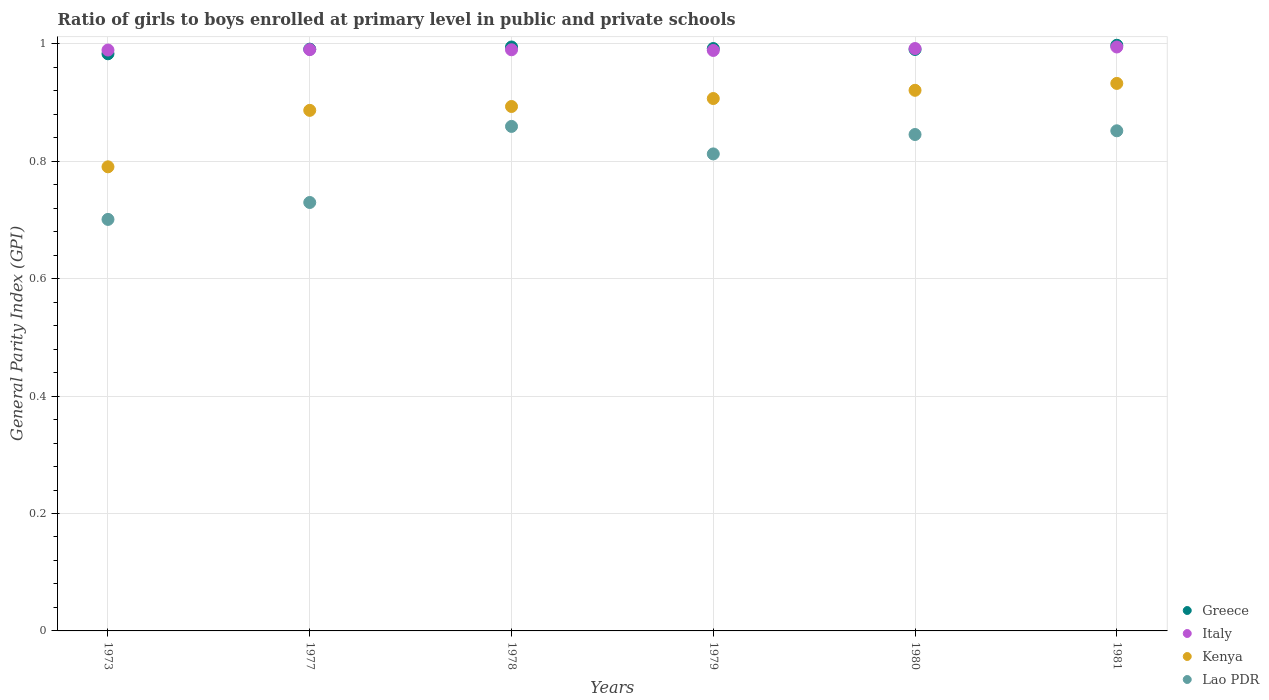Is the number of dotlines equal to the number of legend labels?
Keep it short and to the point. Yes. What is the general parity index in Italy in 1980?
Keep it short and to the point. 0.99. Across all years, what is the maximum general parity index in Italy?
Offer a terse response. 0.99. Across all years, what is the minimum general parity index in Kenya?
Make the answer very short. 0.79. In which year was the general parity index in Italy maximum?
Offer a terse response. 1981. What is the total general parity index in Lao PDR in the graph?
Ensure brevity in your answer.  4.8. What is the difference between the general parity index in Lao PDR in 1978 and that in 1980?
Offer a very short reply. 0.01. What is the difference between the general parity index in Lao PDR in 1973 and the general parity index in Italy in 1977?
Provide a short and direct response. -0.29. What is the average general parity index in Italy per year?
Provide a succinct answer. 0.99. In the year 1978, what is the difference between the general parity index in Italy and general parity index in Greece?
Offer a very short reply. -0. What is the ratio of the general parity index in Kenya in 1978 to that in 1980?
Give a very brief answer. 0.97. Is the general parity index in Kenya in 1973 less than that in 1978?
Your answer should be very brief. Yes. What is the difference between the highest and the second highest general parity index in Greece?
Provide a short and direct response. 0. What is the difference between the highest and the lowest general parity index in Kenya?
Make the answer very short. 0.14. In how many years, is the general parity index in Greece greater than the average general parity index in Greece taken over all years?
Ensure brevity in your answer.  3. Does the general parity index in Lao PDR monotonically increase over the years?
Give a very brief answer. No. Is the general parity index in Kenya strictly greater than the general parity index in Lao PDR over the years?
Give a very brief answer. Yes. How many dotlines are there?
Make the answer very short. 4. What is the difference between two consecutive major ticks on the Y-axis?
Your answer should be very brief. 0.2. Does the graph contain grids?
Give a very brief answer. Yes. How are the legend labels stacked?
Ensure brevity in your answer.  Vertical. What is the title of the graph?
Give a very brief answer. Ratio of girls to boys enrolled at primary level in public and private schools. What is the label or title of the X-axis?
Ensure brevity in your answer.  Years. What is the label or title of the Y-axis?
Your answer should be compact. General Parity Index (GPI). What is the General Parity Index (GPI) in Greece in 1973?
Your answer should be very brief. 0.98. What is the General Parity Index (GPI) of Italy in 1973?
Provide a succinct answer. 0.99. What is the General Parity Index (GPI) in Kenya in 1973?
Your answer should be compact. 0.79. What is the General Parity Index (GPI) in Lao PDR in 1973?
Keep it short and to the point. 0.7. What is the General Parity Index (GPI) of Greece in 1977?
Your answer should be compact. 0.99. What is the General Parity Index (GPI) in Italy in 1977?
Give a very brief answer. 0.99. What is the General Parity Index (GPI) in Kenya in 1977?
Offer a very short reply. 0.89. What is the General Parity Index (GPI) of Lao PDR in 1977?
Provide a short and direct response. 0.73. What is the General Parity Index (GPI) in Greece in 1978?
Offer a very short reply. 0.99. What is the General Parity Index (GPI) in Italy in 1978?
Your response must be concise. 0.99. What is the General Parity Index (GPI) in Kenya in 1978?
Ensure brevity in your answer.  0.89. What is the General Parity Index (GPI) in Lao PDR in 1978?
Keep it short and to the point. 0.86. What is the General Parity Index (GPI) in Greece in 1979?
Give a very brief answer. 0.99. What is the General Parity Index (GPI) in Italy in 1979?
Keep it short and to the point. 0.99. What is the General Parity Index (GPI) in Kenya in 1979?
Make the answer very short. 0.91. What is the General Parity Index (GPI) of Lao PDR in 1979?
Your answer should be very brief. 0.81. What is the General Parity Index (GPI) of Greece in 1980?
Give a very brief answer. 0.99. What is the General Parity Index (GPI) of Italy in 1980?
Offer a very short reply. 0.99. What is the General Parity Index (GPI) in Kenya in 1980?
Offer a terse response. 0.92. What is the General Parity Index (GPI) in Lao PDR in 1980?
Provide a short and direct response. 0.85. What is the General Parity Index (GPI) of Greece in 1981?
Your response must be concise. 1. What is the General Parity Index (GPI) in Italy in 1981?
Ensure brevity in your answer.  0.99. What is the General Parity Index (GPI) of Kenya in 1981?
Provide a succinct answer. 0.93. What is the General Parity Index (GPI) in Lao PDR in 1981?
Your answer should be very brief. 0.85. Across all years, what is the maximum General Parity Index (GPI) of Greece?
Offer a very short reply. 1. Across all years, what is the maximum General Parity Index (GPI) of Italy?
Ensure brevity in your answer.  0.99. Across all years, what is the maximum General Parity Index (GPI) in Kenya?
Ensure brevity in your answer.  0.93. Across all years, what is the maximum General Parity Index (GPI) in Lao PDR?
Your answer should be compact. 0.86. Across all years, what is the minimum General Parity Index (GPI) in Greece?
Your answer should be compact. 0.98. Across all years, what is the minimum General Parity Index (GPI) in Italy?
Give a very brief answer. 0.99. Across all years, what is the minimum General Parity Index (GPI) of Kenya?
Your answer should be very brief. 0.79. Across all years, what is the minimum General Parity Index (GPI) of Lao PDR?
Provide a succinct answer. 0.7. What is the total General Parity Index (GPI) of Greece in the graph?
Your response must be concise. 5.95. What is the total General Parity Index (GPI) of Italy in the graph?
Offer a terse response. 5.95. What is the total General Parity Index (GPI) in Kenya in the graph?
Provide a short and direct response. 5.33. What is the total General Parity Index (GPI) of Lao PDR in the graph?
Provide a short and direct response. 4.8. What is the difference between the General Parity Index (GPI) of Greece in 1973 and that in 1977?
Your response must be concise. -0.01. What is the difference between the General Parity Index (GPI) in Italy in 1973 and that in 1977?
Give a very brief answer. -0. What is the difference between the General Parity Index (GPI) of Kenya in 1973 and that in 1977?
Your answer should be compact. -0.1. What is the difference between the General Parity Index (GPI) in Lao PDR in 1973 and that in 1977?
Offer a very short reply. -0.03. What is the difference between the General Parity Index (GPI) of Greece in 1973 and that in 1978?
Give a very brief answer. -0.01. What is the difference between the General Parity Index (GPI) of Italy in 1973 and that in 1978?
Provide a short and direct response. -0. What is the difference between the General Parity Index (GPI) of Kenya in 1973 and that in 1978?
Make the answer very short. -0.1. What is the difference between the General Parity Index (GPI) in Lao PDR in 1973 and that in 1978?
Your answer should be compact. -0.16. What is the difference between the General Parity Index (GPI) of Greece in 1973 and that in 1979?
Keep it short and to the point. -0.01. What is the difference between the General Parity Index (GPI) of Italy in 1973 and that in 1979?
Provide a short and direct response. 0. What is the difference between the General Parity Index (GPI) of Kenya in 1973 and that in 1979?
Your response must be concise. -0.12. What is the difference between the General Parity Index (GPI) of Lao PDR in 1973 and that in 1979?
Your answer should be very brief. -0.11. What is the difference between the General Parity Index (GPI) in Greece in 1973 and that in 1980?
Keep it short and to the point. -0.01. What is the difference between the General Parity Index (GPI) in Italy in 1973 and that in 1980?
Make the answer very short. -0. What is the difference between the General Parity Index (GPI) of Kenya in 1973 and that in 1980?
Provide a succinct answer. -0.13. What is the difference between the General Parity Index (GPI) of Lao PDR in 1973 and that in 1980?
Give a very brief answer. -0.14. What is the difference between the General Parity Index (GPI) of Greece in 1973 and that in 1981?
Make the answer very short. -0.01. What is the difference between the General Parity Index (GPI) in Italy in 1973 and that in 1981?
Offer a very short reply. -0.01. What is the difference between the General Parity Index (GPI) in Kenya in 1973 and that in 1981?
Provide a succinct answer. -0.14. What is the difference between the General Parity Index (GPI) of Lao PDR in 1973 and that in 1981?
Ensure brevity in your answer.  -0.15. What is the difference between the General Parity Index (GPI) of Greece in 1977 and that in 1978?
Provide a succinct answer. -0. What is the difference between the General Parity Index (GPI) in Kenya in 1977 and that in 1978?
Keep it short and to the point. -0.01. What is the difference between the General Parity Index (GPI) of Lao PDR in 1977 and that in 1978?
Offer a very short reply. -0.13. What is the difference between the General Parity Index (GPI) in Greece in 1977 and that in 1979?
Provide a short and direct response. -0. What is the difference between the General Parity Index (GPI) of Italy in 1977 and that in 1979?
Provide a succinct answer. 0. What is the difference between the General Parity Index (GPI) in Kenya in 1977 and that in 1979?
Your answer should be compact. -0.02. What is the difference between the General Parity Index (GPI) of Lao PDR in 1977 and that in 1979?
Keep it short and to the point. -0.08. What is the difference between the General Parity Index (GPI) in Greece in 1977 and that in 1980?
Provide a succinct answer. 0. What is the difference between the General Parity Index (GPI) of Italy in 1977 and that in 1980?
Give a very brief answer. -0. What is the difference between the General Parity Index (GPI) in Kenya in 1977 and that in 1980?
Keep it short and to the point. -0.03. What is the difference between the General Parity Index (GPI) in Lao PDR in 1977 and that in 1980?
Provide a short and direct response. -0.12. What is the difference between the General Parity Index (GPI) of Greece in 1977 and that in 1981?
Provide a succinct answer. -0.01. What is the difference between the General Parity Index (GPI) of Italy in 1977 and that in 1981?
Provide a short and direct response. -0. What is the difference between the General Parity Index (GPI) of Kenya in 1977 and that in 1981?
Offer a very short reply. -0.05. What is the difference between the General Parity Index (GPI) in Lao PDR in 1977 and that in 1981?
Provide a short and direct response. -0.12. What is the difference between the General Parity Index (GPI) in Greece in 1978 and that in 1979?
Keep it short and to the point. 0. What is the difference between the General Parity Index (GPI) of Italy in 1978 and that in 1979?
Keep it short and to the point. 0. What is the difference between the General Parity Index (GPI) in Kenya in 1978 and that in 1979?
Your answer should be very brief. -0.01. What is the difference between the General Parity Index (GPI) in Lao PDR in 1978 and that in 1979?
Make the answer very short. 0.05. What is the difference between the General Parity Index (GPI) in Greece in 1978 and that in 1980?
Keep it short and to the point. 0. What is the difference between the General Parity Index (GPI) in Italy in 1978 and that in 1980?
Provide a short and direct response. -0. What is the difference between the General Parity Index (GPI) in Kenya in 1978 and that in 1980?
Your answer should be compact. -0.03. What is the difference between the General Parity Index (GPI) of Lao PDR in 1978 and that in 1980?
Ensure brevity in your answer.  0.01. What is the difference between the General Parity Index (GPI) in Greece in 1978 and that in 1981?
Ensure brevity in your answer.  -0. What is the difference between the General Parity Index (GPI) of Italy in 1978 and that in 1981?
Your answer should be compact. -0. What is the difference between the General Parity Index (GPI) of Kenya in 1978 and that in 1981?
Your answer should be compact. -0.04. What is the difference between the General Parity Index (GPI) in Lao PDR in 1978 and that in 1981?
Ensure brevity in your answer.  0.01. What is the difference between the General Parity Index (GPI) in Greece in 1979 and that in 1980?
Offer a terse response. 0. What is the difference between the General Parity Index (GPI) of Italy in 1979 and that in 1980?
Offer a very short reply. -0. What is the difference between the General Parity Index (GPI) of Kenya in 1979 and that in 1980?
Your response must be concise. -0.01. What is the difference between the General Parity Index (GPI) of Lao PDR in 1979 and that in 1980?
Provide a succinct answer. -0.03. What is the difference between the General Parity Index (GPI) in Greece in 1979 and that in 1981?
Your answer should be very brief. -0.01. What is the difference between the General Parity Index (GPI) of Italy in 1979 and that in 1981?
Ensure brevity in your answer.  -0.01. What is the difference between the General Parity Index (GPI) of Kenya in 1979 and that in 1981?
Ensure brevity in your answer.  -0.03. What is the difference between the General Parity Index (GPI) of Lao PDR in 1979 and that in 1981?
Keep it short and to the point. -0.04. What is the difference between the General Parity Index (GPI) in Greece in 1980 and that in 1981?
Give a very brief answer. -0.01. What is the difference between the General Parity Index (GPI) in Italy in 1980 and that in 1981?
Provide a short and direct response. -0. What is the difference between the General Parity Index (GPI) of Kenya in 1980 and that in 1981?
Keep it short and to the point. -0.01. What is the difference between the General Parity Index (GPI) of Lao PDR in 1980 and that in 1981?
Offer a very short reply. -0.01. What is the difference between the General Parity Index (GPI) in Greece in 1973 and the General Parity Index (GPI) in Italy in 1977?
Provide a succinct answer. -0.01. What is the difference between the General Parity Index (GPI) in Greece in 1973 and the General Parity Index (GPI) in Kenya in 1977?
Ensure brevity in your answer.  0.1. What is the difference between the General Parity Index (GPI) of Greece in 1973 and the General Parity Index (GPI) of Lao PDR in 1977?
Ensure brevity in your answer.  0.25. What is the difference between the General Parity Index (GPI) of Italy in 1973 and the General Parity Index (GPI) of Kenya in 1977?
Make the answer very short. 0.1. What is the difference between the General Parity Index (GPI) in Italy in 1973 and the General Parity Index (GPI) in Lao PDR in 1977?
Your response must be concise. 0.26. What is the difference between the General Parity Index (GPI) of Kenya in 1973 and the General Parity Index (GPI) of Lao PDR in 1977?
Your response must be concise. 0.06. What is the difference between the General Parity Index (GPI) of Greece in 1973 and the General Parity Index (GPI) of Italy in 1978?
Ensure brevity in your answer.  -0.01. What is the difference between the General Parity Index (GPI) of Greece in 1973 and the General Parity Index (GPI) of Kenya in 1978?
Ensure brevity in your answer.  0.09. What is the difference between the General Parity Index (GPI) in Greece in 1973 and the General Parity Index (GPI) in Lao PDR in 1978?
Ensure brevity in your answer.  0.12. What is the difference between the General Parity Index (GPI) of Italy in 1973 and the General Parity Index (GPI) of Kenya in 1978?
Offer a very short reply. 0.1. What is the difference between the General Parity Index (GPI) in Italy in 1973 and the General Parity Index (GPI) in Lao PDR in 1978?
Your answer should be very brief. 0.13. What is the difference between the General Parity Index (GPI) of Kenya in 1973 and the General Parity Index (GPI) of Lao PDR in 1978?
Your response must be concise. -0.07. What is the difference between the General Parity Index (GPI) in Greece in 1973 and the General Parity Index (GPI) in Italy in 1979?
Your answer should be compact. -0.01. What is the difference between the General Parity Index (GPI) of Greece in 1973 and the General Parity Index (GPI) of Kenya in 1979?
Provide a short and direct response. 0.08. What is the difference between the General Parity Index (GPI) of Greece in 1973 and the General Parity Index (GPI) of Lao PDR in 1979?
Offer a very short reply. 0.17. What is the difference between the General Parity Index (GPI) of Italy in 1973 and the General Parity Index (GPI) of Kenya in 1979?
Provide a succinct answer. 0.08. What is the difference between the General Parity Index (GPI) in Italy in 1973 and the General Parity Index (GPI) in Lao PDR in 1979?
Keep it short and to the point. 0.18. What is the difference between the General Parity Index (GPI) of Kenya in 1973 and the General Parity Index (GPI) of Lao PDR in 1979?
Keep it short and to the point. -0.02. What is the difference between the General Parity Index (GPI) in Greece in 1973 and the General Parity Index (GPI) in Italy in 1980?
Provide a succinct answer. -0.01. What is the difference between the General Parity Index (GPI) in Greece in 1973 and the General Parity Index (GPI) in Kenya in 1980?
Provide a succinct answer. 0.06. What is the difference between the General Parity Index (GPI) in Greece in 1973 and the General Parity Index (GPI) in Lao PDR in 1980?
Your response must be concise. 0.14. What is the difference between the General Parity Index (GPI) in Italy in 1973 and the General Parity Index (GPI) in Kenya in 1980?
Make the answer very short. 0.07. What is the difference between the General Parity Index (GPI) in Italy in 1973 and the General Parity Index (GPI) in Lao PDR in 1980?
Keep it short and to the point. 0.14. What is the difference between the General Parity Index (GPI) in Kenya in 1973 and the General Parity Index (GPI) in Lao PDR in 1980?
Give a very brief answer. -0.06. What is the difference between the General Parity Index (GPI) of Greece in 1973 and the General Parity Index (GPI) of Italy in 1981?
Offer a very short reply. -0.01. What is the difference between the General Parity Index (GPI) in Greece in 1973 and the General Parity Index (GPI) in Kenya in 1981?
Your answer should be compact. 0.05. What is the difference between the General Parity Index (GPI) of Greece in 1973 and the General Parity Index (GPI) of Lao PDR in 1981?
Keep it short and to the point. 0.13. What is the difference between the General Parity Index (GPI) of Italy in 1973 and the General Parity Index (GPI) of Kenya in 1981?
Provide a short and direct response. 0.06. What is the difference between the General Parity Index (GPI) of Italy in 1973 and the General Parity Index (GPI) of Lao PDR in 1981?
Ensure brevity in your answer.  0.14. What is the difference between the General Parity Index (GPI) of Kenya in 1973 and the General Parity Index (GPI) of Lao PDR in 1981?
Offer a very short reply. -0.06. What is the difference between the General Parity Index (GPI) in Greece in 1977 and the General Parity Index (GPI) in Italy in 1978?
Keep it short and to the point. 0. What is the difference between the General Parity Index (GPI) of Greece in 1977 and the General Parity Index (GPI) of Kenya in 1978?
Keep it short and to the point. 0.1. What is the difference between the General Parity Index (GPI) in Greece in 1977 and the General Parity Index (GPI) in Lao PDR in 1978?
Provide a short and direct response. 0.13. What is the difference between the General Parity Index (GPI) in Italy in 1977 and the General Parity Index (GPI) in Kenya in 1978?
Keep it short and to the point. 0.1. What is the difference between the General Parity Index (GPI) of Italy in 1977 and the General Parity Index (GPI) of Lao PDR in 1978?
Give a very brief answer. 0.13. What is the difference between the General Parity Index (GPI) of Kenya in 1977 and the General Parity Index (GPI) of Lao PDR in 1978?
Make the answer very short. 0.03. What is the difference between the General Parity Index (GPI) in Greece in 1977 and the General Parity Index (GPI) in Italy in 1979?
Provide a short and direct response. 0. What is the difference between the General Parity Index (GPI) of Greece in 1977 and the General Parity Index (GPI) of Kenya in 1979?
Your response must be concise. 0.08. What is the difference between the General Parity Index (GPI) in Greece in 1977 and the General Parity Index (GPI) in Lao PDR in 1979?
Provide a short and direct response. 0.18. What is the difference between the General Parity Index (GPI) in Italy in 1977 and the General Parity Index (GPI) in Kenya in 1979?
Offer a very short reply. 0.08. What is the difference between the General Parity Index (GPI) in Italy in 1977 and the General Parity Index (GPI) in Lao PDR in 1979?
Offer a terse response. 0.18. What is the difference between the General Parity Index (GPI) of Kenya in 1977 and the General Parity Index (GPI) of Lao PDR in 1979?
Provide a short and direct response. 0.07. What is the difference between the General Parity Index (GPI) in Greece in 1977 and the General Parity Index (GPI) in Italy in 1980?
Keep it short and to the point. -0. What is the difference between the General Parity Index (GPI) in Greece in 1977 and the General Parity Index (GPI) in Kenya in 1980?
Provide a short and direct response. 0.07. What is the difference between the General Parity Index (GPI) of Greece in 1977 and the General Parity Index (GPI) of Lao PDR in 1980?
Your response must be concise. 0.15. What is the difference between the General Parity Index (GPI) of Italy in 1977 and the General Parity Index (GPI) of Kenya in 1980?
Give a very brief answer. 0.07. What is the difference between the General Parity Index (GPI) in Italy in 1977 and the General Parity Index (GPI) in Lao PDR in 1980?
Keep it short and to the point. 0.14. What is the difference between the General Parity Index (GPI) of Kenya in 1977 and the General Parity Index (GPI) of Lao PDR in 1980?
Offer a terse response. 0.04. What is the difference between the General Parity Index (GPI) in Greece in 1977 and the General Parity Index (GPI) in Italy in 1981?
Give a very brief answer. -0. What is the difference between the General Parity Index (GPI) in Greece in 1977 and the General Parity Index (GPI) in Kenya in 1981?
Provide a short and direct response. 0.06. What is the difference between the General Parity Index (GPI) in Greece in 1977 and the General Parity Index (GPI) in Lao PDR in 1981?
Offer a very short reply. 0.14. What is the difference between the General Parity Index (GPI) in Italy in 1977 and the General Parity Index (GPI) in Kenya in 1981?
Make the answer very short. 0.06. What is the difference between the General Parity Index (GPI) of Italy in 1977 and the General Parity Index (GPI) of Lao PDR in 1981?
Offer a terse response. 0.14. What is the difference between the General Parity Index (GPI) in Kenya in 1977 and the General Parity Index (GPI) in Lao PDR in 1981?
Make the answer very short. 0.03. What is the difference between the General Parity Index (GPI) in Greece in 1978 and the General Parity Index (GPI) in Italy in 1979?
Make the answer very short. 0.01. What is the difference between the General Parity Index (GPI) in Greece in 1978 and the General Parity Index (GPI) in Kenya in 1979?
Your response must be concise. 0.09. What is the difference between the General Parity Index (GPI) in Greece in 1978 and the General Parity Index (GPI) in Lao PDR in 1979?
Ensure brevity in your answer.  0.18. What is the difference between the General Parity Index (GPI) of Italy in 1978 and the General Parity Index (GPI) of Kenya in 1979?
Your answer should be very brief. 0.08. What is the difference between the General Parity Index (GPI) of Italy in 1978 and the General Parity Index (GPI) of Lao PDR in 1979?
Your answer should be compact. 0.18. What is the difference between the General Parity Index (GPI) in Kenya in 1978 and the General Parity Index (GPI) in Lao PDR in 1979?
Your answer should be compact. 0.08. What is the difference between the General Parity Index (GPI) of Greece in 1978 and the General Parity Index (GPI) of Italy in 1980?
Ensure brevity in your answer.  0. What is the difference between the General Parity Index (GPI) of Greece in 1978 and the General Parity Index (GPI) of Kenya in 1980?
Ensure brevity in your answer.  0.07. What is the difference between the General Parity Index (GPI) in Greece in 1978 and the General Parity Index (GPI) in Lao PDR in 1980?
Keep it short and to the point. 0.15. What is the difference between the General Parity Index (GPI) of Italy in 1978 and the General Parity Index (GPI) of Kenya in 1980?
Provide a succinct answer. 0.07. What is the difference between the General Parity Index (GPI) of Italy in 1978 and the General Parity Index (GPI) of Lao PDR in 1980?
Provide a succinct answer. 0.14. What is the difference between the General Parity Index (GPI) of Kenya in 1978 and the General Parity Index (GPI) of Lao PDR in 1980?
Offer a very short reply. 0.05. What is the difference between the General Parity Index (GPI) of Greece in 1978 and the General Parity Index (GPI) of Kenya in 1981?
Make the answer very short. 0.06. What is the difference between the General Parity Index (GPI) in Greece in 1978 and the General Parity Index (GPI) in Lao PDR in 1981?
Your answer should be compact. 0.14. What is the difference between the General Parity Index (GPI) in Italy in 1978 and the General Parity Index (GPI) in Kenya in 1981?
Offer a very short reply. 0.06. What is the difference between the General Parity Index (GPI) in Italy in 1978 and the General Parity Index (GPI) in Lao PDR in 1981?
Your answer should be very brief. 0.14. What is the difference between the General Parity Index (GPI) of Kenya in 1978 and the General Parity Index (GPI) of Lao PDR in 1981?
Your response must be concise. 0.04. What is the difference between the General Parity Index (GPI) of Greece in 1979 and the General Parity Index (GPI) of Italy in 1980?
Offer a very short reply. 0. What is the difference between the General Parity Index (GPI) in Greece in 1979 and the General Parity Index (GPI) in Kenya in 1980?
Provide a succinct answer. 0.07. What is the difference between the General Parity Index (GPI) in Greece in 1979 and the General Parity Index (GPI) in Lao PDR in 1980?
Ensure brevity in your answer.  0.15. What is the difference between the General Parity Index (GPI) of Italy in 1979 and the General Parity Index (GPI) of Kenya in 1980?
Offer a very short reply. 0.07. What is the difference between the General Parity Index (GPI) in Italy in 1979 and the General Parity Index (GPI) in Lao PDR in 1980?
Keep it short and to the point. 0.14. What is the difference between the General Parity Index (GPI) in Kenya in 1979 and the General Parity Index (GPI) in Lao PDR in 1980?
Keep it short and to the point. 0.06. What is the difference between the General Parity Index (GPI) of Greece in 1979 and the General Parity Index (GPI) of Italy in 1981?
Make the answer very short. -0. What is the difference between the General Parity Index (GPI) in Greece in 1979 and the General Parity Index (GPI) in Kenya in 1981?
Give a very brief answer. 0.06. What is the difference between the General Parity Index (GPI) of Greece in 1979 and the General Parity Index (GPI) of Lao PDR in 1981?
Your response must be concise. 0.14. What is the difference between the General Parity Index (GPI) in Italy in 1979 and the General Parity Index (GPI) in Kenya in 1981?
Your answer should be compact. 0.06. What is the difference between the General Parity Index (GPI) in Italy in 1979 and the General Parity Index (GPI) in Lao PDR in 1981?
Give a very brief answer. 0.14. What is the difference between the General Parity Index (GPI) in Kenya in 1979 and the General Parity Index (GPI) in Lao PDR in 1981?
Your response must be concise. 0.06. What is the difference between the General Parity Index (GPI) of Greece in 1980 and the General Parity Index (GPI) of Italy in 1981?
Ensure brevity in your answer.  -0. What is the difference between the General Parity Index (GPI) in Greece in 1980 and the General Parity Index (GPI) in Kenya in 1981?
Keep it short and to the point. 0.06. What is the difference between the General Parity Index (GPI) of Greece in 1980 and the General Parity Index (GPI) of Lao PDR in 1981?
Your response must be concise. 0.14. What is the difference between the General Parity Index (GPI) of Italy in 1980 and the General Parity Index (GPI) of Kenya in 1981?
Make the answer very short. 0.06. What is the difference between the General Parity Index (GPI) of Italy in 1980 and the General Parity Index (GPI) of Lao PDR in 1981?
Offer a terse response. 0.14. What is the difference between the General Parity Index (GPI) in Kenya in 1980 and the General Parity Index (GPI) in Lao PDR in 1981?
Offer a very short reply. 0.07. What is the average General Parity Index (GPI) in Italy per year?
Offer a very short reply. 0.99. What is the average General Parity Index (GPI) of Kenya per year?
Offer a terse response. 0.89. What is the average General Parity Index (GPI) in Lao PDR per year?
Make the answer very short. 0.8. In the year 1973, what is the difference between the General Parity Index (GPI) of Greece and General Parity Index (GPI) of Italy?
Ensure brevity in your answer.  -0.01. In the year 1973, what is the difference between the General Parity Index (GPI) in Greece and General Parity Index (GPI) in Kenya?
Your answer should be very brief. 0.19. In the year 1973, what is the difference between the General Parity Index (GPI) in Greece and General Parity Index (GPI) in Lao PDR?
Offer a very short reply. 0.28. In the year 1973, what is the difference between the General Parity Index (GPI) of Italy and General Parity Index (GPI) of Kenya?
Ensure brevity in your answer.  0.2. In the year 1973, what is the difference between the General Parity Index (GPI) of Italy and General Parity Index (GPI) of Lao PDR?
Provide a short and direct response. 0.29. In the year 1973, what is the difference between the General Parity Index (GPI) in Kenya and General Parity Index (GPI) in Lao PDR?
Make the answer very short. 0.09. In the year 1977, what is the difference between the General Parity Index (GPI) in Greece and General Parity Index (GPI) in Italy?
Give a very brief answer. 0. In the year 1977, what is the difference between the General Parity Index (GPI) in Greece and General Parity Index (GPI) in Kenya?
Provide a short and direct response. 0.1. In the year 1977, what is the difference between the General Parity Index (GPI) of Greece and General Parity Index (GPI) of Lao PDR?
Offer a very short reply. 0.26. In the year 1977, what is the difference between the General Parity Index (GPI) in Italy and General Parity Index (GPI) in Kenya?
Your answer should be compact. 0.1. In the year 1977, what is the difference between the General Parity Index (GPI) in Italy and General Parity Index (GPI) in Lao PDR?
Keep it short and to the point. 0.26. In the year 1977, what is the difference between the General Parity Index (GPI) in Kenya and General Parity Index (GPI) in Lao PDR?
Provide a succinct answer. 0.16. In the year 1978, what is the difference between the General Parity Index (GPI) in Greece and General Parity Index (GPI) in Italy?
Provide a succinct answer. 0. In the year 1978, what is the difference between the General Parity Index (GPI) in Greece and General Parity Index (GPI) in Kenya?
Offer a terse response. 0.1. In the year 1978, what is the difference between the General Parity Index (GPI) of Greece and General Parity Index (GPI) of Lao PDR?
Keep it short and to the point. 0.14. In the year 1978, what is the difference between the General Parity Index (GPI) of Italy and General Parity Index (GPI) of Kenya?
Provide a short and direct response. 0.1. In the year 1978, what is the difference between the General Parity Index (GPI) of Italy and General Parity Index (GPI) of Lao PDR?
Your response must be concise. 0.13. In the year 1978, what is the difference between the General Parity Index (GPI) of Kenya and General Parity Index (GPI) of Lao PDR?
Make the answer very short. 0.03. In the year 1979, what is the difference between the General Parity Index (GPI) of Greece and General Parity Index (GPI) of Italy?
Make the answer very short. 0. In the year 1979, what is the difference between the General Parity Index (GPI) in Greece and General Parity Index (GPI) in Kenya?
Give a very brief answer. 0.09. In the year 1979, what is the difference between the General Parity Index (GPI) in Greece and General Parity Index (GPI) in Lao PDR?
Make the answer very short. 0.18. In the year 1979, what is the difference between the General Parity Index (GPI) of Italy and General Parity Index (GPI) of Kenya?
Your answer should be compact. 0.08. In the year 1979, what is the difference between the General Parity Index (GPI) of Italy and General Parity Index (GPI) of Lao PDR?
Your answer should be very brief. 0.18. In the year 1979, what is the difference between the General Parity Index (GPI) of Kenya and General Parity Index (GPI) of Lao PDR?
Make the answer very short. 0.09. In the year 1980, what is the difference between the General Parity Index (GPI) of Greece and General Parity Index (GPI) of Italy?
Offer a very short reply. -0. In the year 1980, what is the difference between the General Parity Index (GPI) in Greece and General Parity Index (GPI) in Kenya?
Your answer should be very brief. 0.07. In the year 1980, what is the difference between the General Parity Index (GPI) in Greece and General Parity Index (GPI) in Lao PDR?
Ensure brevity in your answer.  0.14. In the year 1980, what is the difference between the General Parity Index (GPI) of Italy and General Parity Index (GPI) of Kenya?
Make the answer very short. 0.07. In the year 1980, what is the difference between the General Parity Index (GPI) of Italy and General Parity Index (GPI) of Lao PDR?
Keep it short and to the point. 0.15. In the year 1980, what is the difference between the General Parity Index (GPI) of Kenya and General Parity Index (GPI) of Lao PDR?
Provide a succinct answer. 0.08. In the year 1981, what is the difference between the General Parity Index (GPI) in Greece and General Parity Index (GPI) in Italy?
Your answer should be very brief. 0. In the year 1981, what is the difference between the General Parity Index (GPI) of Greece and General Parity Index (GPI) of Kenya?
Provide a succinct answer. 0.07. In the year 1981, what is the difference between the General Parity Index (GPI) of Greece and General Parity Index (GPI) of Lao PDR?
Your answer should be compact. 0.15. In the year 1981, what is the difference between the General Parity Index (GPI) in Italy and General Parity Index (GPI) in Kenya?
Give a very brief answer. 0.06. In the year 1981, what is the difference between the General Parity Index (GPI) in Italy and General Parity Index (GPI) in Lao PDR?
Make the answer very short. 0.14. In the year 1981, what is the difference between the General Parity Index (GPI) of Kenya and General Parity Index (GPI) of Lao PDR?
Offer a terse response. 0.08. What is the ratio of the General Parity Index (GPI) of Kenya in 1973 to that in 1977?
Provide a succinct answer. 0.89. What is the ratio of the General Parity Index (GPI) of Lao PDR in 1973 to that in 1977?
Your answer should be very brief. 0.96. What is the ratio of the General Parity Index (GPI) in Greece in 1973 to that in 1978?
Provide a short and direct response. 0.99. What is the ratio of the General Parity Index (GPI) of Italy in 1973 to that in 1978?
Offer a terse response. 1. What is the ratio of the General Parity Index (GPI) of Kenya in 1973 to that in 1978?
Give a very brief answer. 0.89. What is the ratio of the General Parity Index (GPI) in Lao PDR in 1973 to that in 1978?
Ensure brevity in your answer.  0.82. What is the ratio of the General Parity Index (GPI) in Italy in 1973 to that in 1979?
Offer a very short reply. 1. What is the ratio of the General Parity Index (GPI) in Kenya in 1973 to that in 1979?
Your response must be concise. 0.87. What is the ratio of the General Parity Index (GPI) of Lao PDR in 1973 to that in 1979?
Offer a very short reply. 0.86. What is the ratio of the General Parity Index (GPI) of Italy in 1973 to that in 1980?
Give a very brief answer. 1. What is the ratio of the General Parity Index (GPI) in Kenya in 1973 to that in 1980?
Ensure brevity in your answer.  0.86. What is the ratio of the General Parity Index (GPI) in Lao PDR in 1973 to that in 1980?
Make the answer very short. 0.83. What is the ratio of the General Parity Index (GPI) of Greece in 1973 to that in 1981?
Your answer should be very brief. 0.99. What is the ratio of the General Parity Index (GPI) of Italy in 1973 to that in 1981?
Your answer should be compact. 0.99. What is the ratio of the General Parity Index (GPI) of Kenya in 1973 to that in 1981?
Ensure brevity in your answer.  0.85. What is the ratio of the General Parity Index (GPI) in Lao PDR in 1973 to that in 1981?
Make the answer very short. 0.82. What is the ratio of the General Parity Index (GPI) in Italy in 1977 to that in 1978?
Your answer should be compact. 1. What is the ratio of the General Parity Index (GPI) of Lao PDR in 1977 to that in 1978?
Make the answer very short. 0.85. What is the ratio of the General Parity Index (GPI) of Greece in 1977 to that in 1979?
Provide a succinct answer. 1. What is the ratio of the General Parity Index (GPI) in Italy in 1977 to that in 1979?
Give a very brief answer. 1. What is the ratio of the General Parity Index (GPI) of Kenya in 1977 to that in 1979?
Provide a succinct answer. 0.98. What is the ratio of the General Parity Index (GPI) of Lao PDR in 1977 to that in 1979?
Keep it short and to the point. 0.9. What is the ratio of the General Parity Index (GPI) in Italy in 1977 to that in 1980?
Keep it short and to the point. 1. What is the ratio of the General Parity Index (GPI) of Kenya in 1977 to that in 1980?
Provide a succinct answer. 0.96. What is the ratio of the General Parity Index (GPI) of Lao PDR in 1977 to that in 1980?
Provide a short and direct response. 0.86. What is the ratio of the General Parity Index (GPI) of Greece in 1977 to that in 1981?
Offer a terse response. 0.99. What is the ratio of the General Parity Index (GPI) in Kenya in 1977 to that in 1981?
Provide a short and direct response. 0.95. What is the ratio of the General Parity Index (GPI) in Lao PDR in 1977 to that in 1981?
Ensure brevity in your answer.  0.86. What is the ratio of the General Parity Index (GPI) of Kenya in 1978 to that in 1979?
Provide a short and direct response. 0.98. What is the ratio of the General Parity Index (GPI) of Lao PDR in 1978 to that in 1979?
Your response must be concise. 1.06. What is the ratio of the General Parity Index (GPI) of Greece in 1978 to that in 1980?
Provide a succinct answer. 1. What is the ratio of the General Parity Index (GPI) in Italy in 1978 to that in 1980?
Your response must be concise. 1. What is the ratio of the General Parity Index (GPI) in Kenya in 1978 to that in 1980?
Offer a terse response. 0.97. What is the ratio of the General Parity Index (GPI) in Lao PDR in 1978 to that in 1980?
Ensure brevity in your answer.  1.02. What is the ratio of the General Parity Index (GPI) in Kenya in 1978 to that in 1981?
Your answer should be very brief. 0.96. What is the ratio of the General Parity Index (GPI) in Lao PDR in 1978 to that in 1981?
Offer a very short reply. 1.01. What is the ratio of the General Parity Index (GPI) of Greece in 1979 to that in 1980?
Offer a terse response. 1. What is the ratio of the General Parity Index (GPI) in Italy in 1979 to that in 1980?
Provide a short and direct response. 1. What is the ratio of the General Parity Index (GPI) of Lao PDR in 1979 to that in 1980?
Give a very brief answer. 0.96. What is the ratio of the General Parity Index (GPI) of Italy in 1979 to that in 1981?
Offer a very short reply. 0.99. What is the ratio of the General Parity Index (GPI) of Kenya in 1979 to that in 1981?
Your answer should be very brief. 0.97. What is the ratio of the General Parity Index (GPI) in Lao PDR in 1979 to that in 1981?
Your response must be concise. 0.95. What is the ratio of the General Parity Index (GPI) of Italy in 1980 to that in 1981?
Provide a short and direct response. 1. What is the ratio of the General Parity Index (GPI) in Kenya in 1980 to that in 1981?
Offer a very short reply. 0.99. What is the ratio of the General Parity Index (GPI) in Lao PDR in 1980 to that in 1981?
Your response must be concise. 0.99. What is the difference between the highest and the second highest General Parity Index (GPI) of Greece?
Provide a short and direct response. 0. What is the difference between the highest and the second highest General Parity Index (GPI) of Italy?
Keep it short and to the point. 0. What is the difference between the highest and the second highest General Parity Index (GPI) of Kenya?
Keep it short and to the point. 0.01. What is the difference between the highest and the second highest General Parity Index (GPI) in Lao PDR?
Provide a succinct answer. 0.01. What is the difference between the highest and the lowest General Parity Index (GPI) of Greece?
Offer a very short reply. 0.01. What is the difference between the highest and the lowest General Parity Index (GPI) in Italy?
Your answer should be very brief. 0.01. What is the difference between the highest and the lowest General Parity Index (GPI) of Kenya?
Your response must be concise. 0.14. What is the difference between the highest and the lowest General Parity Index (GPI) of Lao PDR?
Provide a short and direct response. 0.16. 